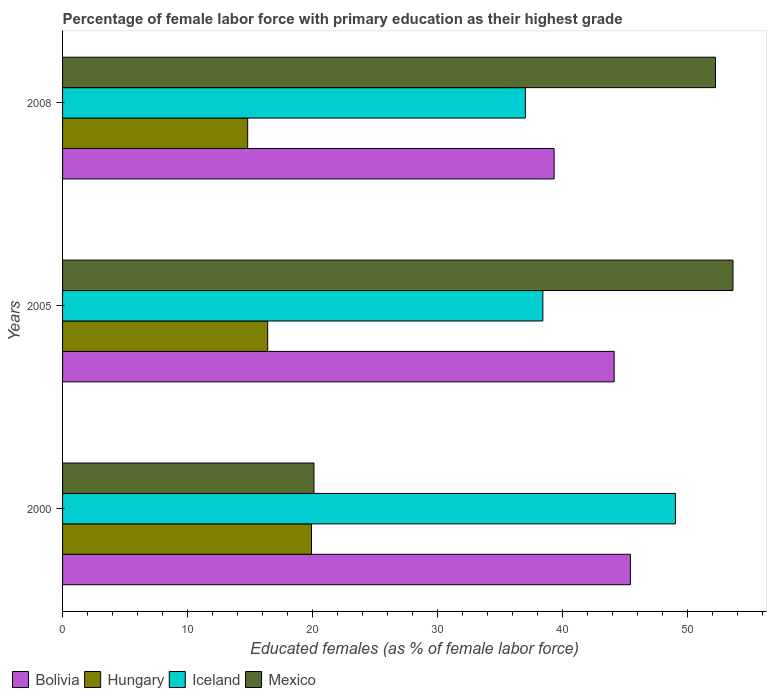How many groups of bars are there?
Offer a terse response. 3. How many bars are there on the 2nd tick from the bottom?
Provide a succinct answer. 4. What is the label of the 2nd group of bars from the top?
Offer a very short reply. 2005. What is the percentage of female labor force with primary education in Hungary in 2008?
Give a very brief answer. 14.8. Across all years, what is the minimum percentage of female labor force with primary education in Bolivia?
Your answer should be compact. 39.3. What is the total percentage of female labor force with primary education in Iceland in the graph?
Ensure brevity in your answer.  124.4. What is the difference between the percentage of female labor force with primary education in Iceland in 2000 and that in 2005?
Provide a succinct answer. 10.6. What is the difference between the percentage of female labor force with primary education in Bolivia in 2000 and the percentage of female labor force with primary education in Hungary in 2008?
Your answer should be compact. 30.6. What is the average percentage of female labor force with primary education in Hungary per year?
Make the answer very short. 17.03. In the year 2005, what is the difference between the percentage of female labor force with primary education in Bolivia and percentage of female labor force with primary education in Iceland?
Provide a succinct answer. 5.7. In how many years, is the percentage of female labor force with primary education in Mexico greater than 48 %?
Ensure brevity in your answer.  2. What is the ratio of the percentage of female labor force with primary education in Bolivia in 2000 to that in 2005?
Make the answer very short. 1.03. Is the difference between the percentage of female labor force with primary education in Bolivia in 2000 and 2008 greater than the difference between the percentage of female labor force with primary education in Iceland in 2000 and 2008?
Provide a short and direct response. No. What is the difference between the highest and the second highest percentage of female labor force with primary education in Mexico?
Your answer should be compact. 1.4. What is the difference between the highest and the lowest percentage of female labor force with primary education in Iceland?
Provide a succinct answer. 12. Is it the case that in every year, the sum of the percentage of female labor force with primary education in Mexico and percentage of female labor force with primary education in Bolivia is greater than the percentage of female labor force with primary education in Iceland?
Offer a terse response. Yes. How many bars are there?
Provide a short and direct response. 12. What is the difference between two consecutive major ticks on the X-axis?
Offer a terse response. 10. Where does the legend appear in the graph?
Your answer should be very brief. Bottom left. How are the legend labels stacked?
Your answer should be very brief. Horizontal. What is the title of the graph?
Your answer should be very brief. Percentage of female labor force with primary education as their highest grade. What is the label or title of the X-axis?
Your answer should be very brief. Educated females (as % of female labor force). What is the Educated females (as % of female labor force) in Bolivia in 2000?
Your answer should be very brief. 45.4. What is the Educated females (as % of female labor force) in Hungary in 2000?
Your answer should be compact. 19.9. What is the Educated females (as % of female labor force) of Mexico in 2000?
Ensure brevity in your answer.  20.1. What is the Educated females (as % of female labor force) in Bolivia in 2005?
Provide a short and direct response. 44.1. What is the Educated females (as % of female labor force) of Hungary in 2005?
Your answer should be very brief. 16.4. What is the Educated females (as % of female labor force) of Iceland in 2005?
Keep it short and to the point. 38.4. What is the Educated females (as % of female labor force) in Mexico in 2005?
Your response must be concise. 53.6. What is the Educated females (as % of female labor force) of Bolivia in 2008?
Ensure brevity in your answer.  39.3. What is the Educated females (as % of female labor force) in Hungary in 2008?
Make the answer very short. 14.8. What is the Educated females (as % of female labor force) in Mexico in 2008?
Your answer should be very brief. 52.2. Across all years, what is the maximum Educated females (as % of female labor force) of Bolivia?
Make the answer very short. 45.4. Across all years, what is the maximum Educated females (as % of female labor force) of Hungary?
Keep it short and to the point. 19.9. Across all years, what is the maximum Educated females (as % of female labor force) of Iceland?
Your response must be concise. 49. Across all years, what is the maximum Educated females (as % of female labor force) of Mexico?
Offer a very short reply. 53.6. Across all years, what is the minimum Educated females (as % of female labor force) of Bolivia?
Provide a short and direct response. 39.3. Across all years, what is the minimum Educated females (as % of female labor force) in Hungary?
Provide a succinct answer. 14.8. Across all years, what is the minimum Educated females (as % of female labor force) in Iceland?
Your answer should be compact. 37. Across all years, what is the minimum Educated females (as % of female labor force) of Mexico?
Give a very brief answer. 20.1. What is the total Educated females (as % of female labor force) in Bolivia in the graph?
Provide a short and direct response. 128.8. What is the total Educated females (as % of female labor force) in Hungary in the graph?
Your answer should be compact. 51.1. What is the total Educated females (as % of female labor force) of Iceland in the graph?
Your answer should be very brief. 124.4. What is the total Educated females (as % of female labor force) in Mexico in the graph?
Offer a terse response. 125.9. What is the difference between the Educated females (as % of female labor force) in Bolivia in 2000 and that in 2005?
Make the answer very short. 1.3. What is the difference between the Educated females (as % of female labor force) in Hungary in 2000 and that in 2005?
Your answer should be very brief. 3.5. What is the difference between the Educated females (as % of female labor force) of Iceland in 2000 and that in 2005?
Offer a terse response. 10.6. What is the difference between the Educated females (as % of female labor force) in Mexico in 2000 and that in 2005?
Make the answer very short. -33.5. What is the difference between the Educated females (as % of female labor force) of Mexico in 2000 and that in 2008?
Offer a terse response. -32.1. What is the difference between the Educated females (as % of female labor force) of Bolivia in 2005 and that in 2008?
Your answer should be very brief. 4.8. What is the difference between the Educated females (as % of female labor force) in Hungary in 2005 and that in 2008?
Keep it short and to the point. 1.6. What is the difference between the Educated females (as % of female labor force) in Bolivia in 2000 and the Educated females (as % of female labor force) in Hungary in 2005?
Ensure brevity in your answer.  29. What is the difference between the Educated females (as % of female labor force) in Hungary in 2000 and the Educated females (as % of female labor force) in Iceland in 2005?
Keep it short and to the point. -18.5. What is the difference between the Educated females (as % of female labor force) of Hungary in 2000 and the Educated females (as % of female labor force) of Mexico in 2005?
Your answer should be very brief. -33.7. What is the difference between the Educated females (as % of female labor force) of Bolivia in 2000 and the Educated females (as % of female labor force) of Hungary in 2008?
Offer a terse response. 30.6. What is the difference between the Educated females (as % of female labor force) in Hungary in 2000 and the Educated females (as % of female labor force) in Iceland in 2008?
Provide a succinct answer. -17.1. What is the difference between the Educated females (as % of female labor force) in Hungary in 2000 and the Educated females (as % of female labor force) in Mexico in 2008?
Your answer should be compact. -32.3. What is the difference between the Educated females (as % of female labor force) of Bolivia in 2005 and the Educated females (as % of female labor force) of Hungary in 2008?
Keep it short and to the point. 29.3. What is the difference between the Educated females (as % of female labor force) in Bolivia in 2005 and the Educated females (as % of female labor force) in Mexico in 2008?
Your answer should be very brief. -8.1. What is the difference between the Educated females (as % of female labor force) of Hungary in 2005 and the Educated females (as % of female labor force) of Iceland in 2008?
Give a very brief answer. -20.6. What is the difference between the Educated females (as % of female labor force) of Hungary in 2005 and the Educated females (as % of female labor force) of Mexico in 2008?
Make the answer very short. -35.8. What is the average Educated females (as % of female labor force) in Bolivia per year?
Your response must be concise. 42.93. What is the average Educated females (as % of female labor force) in Hungary per year?
Give a very brief answer. 17.03. What is the average Educated females (as % of female labor force) in Iceland per year?
Keep it short and to the point. 41.47. What is the average Educated females (as % of female labor force) of Mexico per year?
Your response must be concise. 41.97. In the year 2000, what is the difference between the Educated females (as % of female labor force) in Bolivia and Educated females (as % of female labor force) in Hungary?
Keep it short and to the point. 25.5. In the year 2000, what is the difference between the Educated females (as % of female labor force) in Bolivia and Educated females (as % of female labor force) in Mexico?
Your answer should be compact. 25.3. In the year 2000, what is the difference between the Educated females (as % of female labor force) in Hungary and Educated females (as % of female labor force) in Iceland?
Make the answer very short. -29.1. In the year 2000, what is the difference between the Educated females (as % of female labor force) of Iceland and Educated females (as % of female labor force) of Mexico?
Make the answer very short. 28.9. In the year 2005, what is the difference between the Educated females (as % of female labor force) in Bolivia and Educated females (as % of female labor force) in Hungary?
Offer a terse response. 27.7. In the year 2005, what is the difference between the Educated females (as % of female labor force) in Bolivia and Educated females (as % of female labor force) in Iceland?
Give a very brief answer. 5.7. In the year 2005, what is the difference between the Educated females (as % of female labor force) of Hungary and Educated females (as % of female labor force) of Iceland?
Offer a very short reply. -22. In the year 2005, what is the difference between the Educated females (as % of female labor force) in Hungary and Educated females (as % of female labor force) in Mexico?
Your answer should be compact. -37.2. In the year 2005, what is the difference between the Educated females (as % of female labor force) in Iceland and Educated females (as % of female labor force) in Mexico?
Make the answer very short. -15.2. In the year 2008, what is the difference between the Educated females (as % of female labor force) in Bolivia and Educated females (as % of female labor force) in Iceland?
Your answer should be compact. 2.3. In the year 2008, what is the difference between the Educated females (as % of female labor force) in Bolivia and Educated females (as % of female labor force) in Mexico?
Provide a succinct answer. -12.9. In the year 2008, what is the difference between the Educated females (as % of female labor force) in Hungary and Educated females (as % of female labor force) in Iceland?
Offer a very short reply. -22.2. In the year 2008, what is the difference between the Educated females (as % of female labor force) of Hungary and Educated females (as % of female labor force) of Mexico?
Keep it short and to the point. -37.4. In the year 2008, what is the difference between the Educated females (as % of female labor force) of Iceland and Educated females (as % of female labor force) of Mexico?
Your response must be concise. -15.2. What is the ratio of the Educated females (as % of female labor force) of Bolivia in 2000 to that in 2005?
Make the answer very short. 1.03. What is the ratio of the Educated females (as % of female labor force) of Hungary in 2000 to that in 2005?
Your answer should be compact. 1.21. What is the ratio of the Educated females (as % of female labor force) of Iceland in 2000 to that in 2005?
Offer a terse response. 1.28. What is the ratio of the Educated females (as % of female labor force) of Bolivia in 2000 to that in 2008?
Keep it short and to the point. 1.16. What is the ratio of the Educated females (as % of female labor force) of Hungary in 2000 to that in 2008?
Give a very brief answer. 1.34. What is the ratio of the Educated females (as % of female labor force) of Iceland in 2000 to that in 2008?
Offer a very short reply. 1.32. What is the ratio of the Educated females (as % of female labor force) of Mexico in 2000 to that in 2008?
Keep it short and to the point. 0.39. What is the ratio of the Educated females (as % of female labor force) in Bolivia in 2005 to that in 2008?
Provide a succinct answer. 1.12. What is the ratio of the Educated females (as % of female labor force) in Hungary in 2005 to that in 2008?
Give a very brief answer. 1.11. What is the ratio of the Educated females (as % of female labor force) in Iceland in 2005 to that in 2008?
Offer a very short reply. 1.04. What is the ratio of the Educated females (as % of female labor force) of Mexico in 2005 to that in 2008?
Keep it short and to the point. 1.03. What is the difference between the highest and the second highest Educated females (as % of female labor force) of Iceland?
Offer a very short reply. 10.6. What is the difference between the highest and the second highest Educated females (as % of female labor force) in Mexico?
Offer a terse response. 1.4. What is the difference between the highest and the lowest Educated females (as % of female labor force) in Iceland?
Provide a short and direct response. 12. What is the difference between the highest and the lowest Educated females (as % of female labor force) in Mexico?
Offer a very short reply. 33.5. 